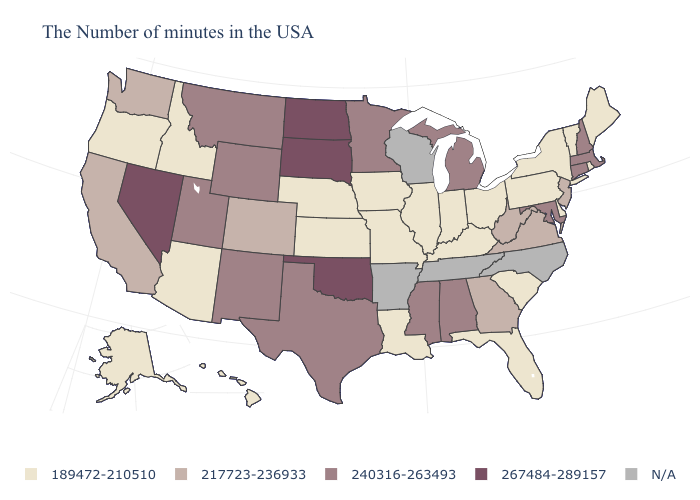Does the first symbol in the legend represent the smallest category?
Concise answer only. Yes. What is the lowest value in the MidWest?
Answer briefly. 189472-210510. What is the value of Arizona?
Give a very brief answer. 189472-210510. Name the states that have a value in the range N/A?
Concise answer only. North Carolina, Tennessee, Wisconsin, Arkansas. Which states have the lowest value in the West?
Be succinct. Arizona, Idaho, Oregon, Alaska, Hawaii. Name the states that have a value in the range 267484-289157?
Short answer required. Oklahoma, South Dakota, North Dakota, Nevada. What is the lowest value in the USA?
Quick response, please. 189472-210510. What is the value of North Dakota?
Give a very brief answer. 267484-289157. What is the value of Massachusetts?
Answer briefly. 240316-263493. Among the states that border Pennsylvania , which have the highest value?
Answer briefly. Maryland. Name the states that have a value in the range N/A?
Answer briefly. North Carolina, Tennessee, Wisconsin, Arkansas. What is the value of Kentucky?
Answer briefly. 189472-210510. 